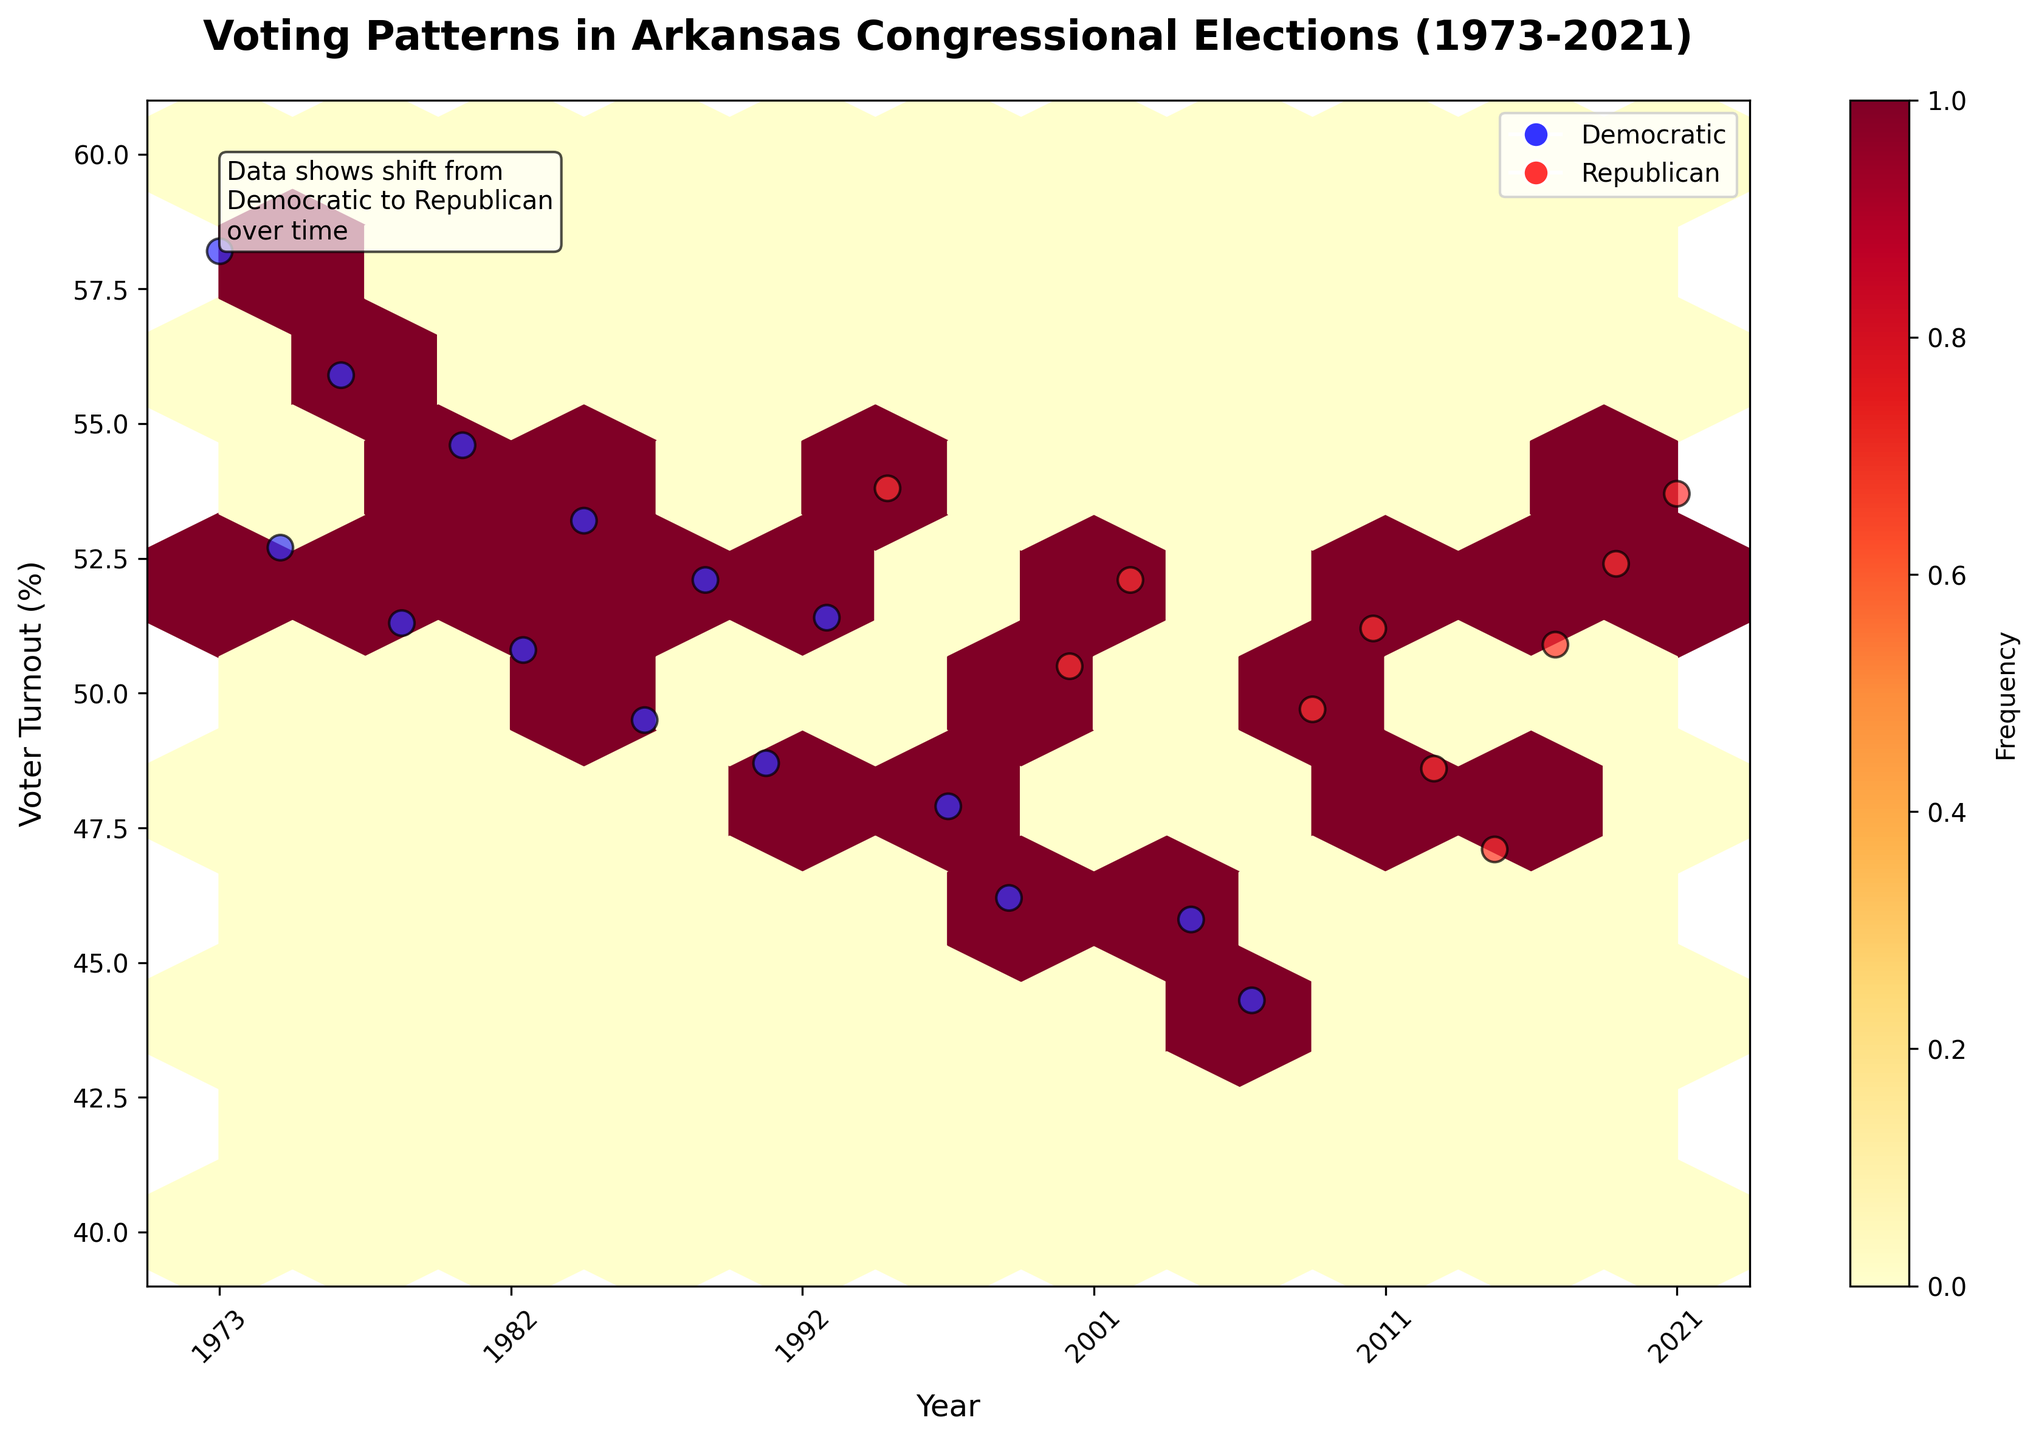What is the title of the plot? The title is prominently displayed at the top of the figure, indicating the subject of the plot.
Answer: Voting Patterns in Arkansas Congressional Elections (1973-2021) What are the x-axis and y-axis labels? The x-axis label is displayed below the horizontal axis representing time, and the y-axis label is displayed beside the vertical axis representing voter turnout.
Answer: Year, Voter Turnout (%) How is the year normalized on the x-axis? The years are scaled between 0 and 1, with 0 representing the earliest year (1973) and 1 representing the latest year (2021), showing actual years in increments as x-axis ticks.
Answer: It is scaled between 0 to 1, with actual years shown as ticks Which parties are represented by blue and red markers in the plot? The plot legend indicates that blue markers represent the Democratic Party and red markers represent the Republican Party.
Answer: Democratic, Republican What does the colorbar represent? The colorbar, labeled "Frequency," indicates how often certain voter turnout and year combinations appear, with more frequent combinations indicated by darker colors.
Answer: Frequency Which party has more scattered data points in recent years (after 2000)? Observing the scatter plot, more red markers (Republican) are present in recent years, indicating their dominance.
Answer: Republican What is the general trend in voter turnout over the years? By following the distribution of points and hexbin colors, there is a noticeable decline in voter turnout percentages over time.
Answer: Declining How many bins were used to create the hexbin plot? The gridsize in the code specifies that 10 bins were used to create the hexbin plot, setting the number of hexagons across the plot.
Answer: 10 Positionally, where is the annotation located, and what does it say? The annotation is located in the upper left corner of the plot area, highlighting a shift from Democratic to Republican dominance over time.
Answer: Upper left; Data shows shift from Democratic to Republican over time During which period was the Democratic Party more prevalent? Based on the concentration and color of blue markers, Democratic prevalence is higher before the mid-1990s.
Answer: Before mid-1990s 